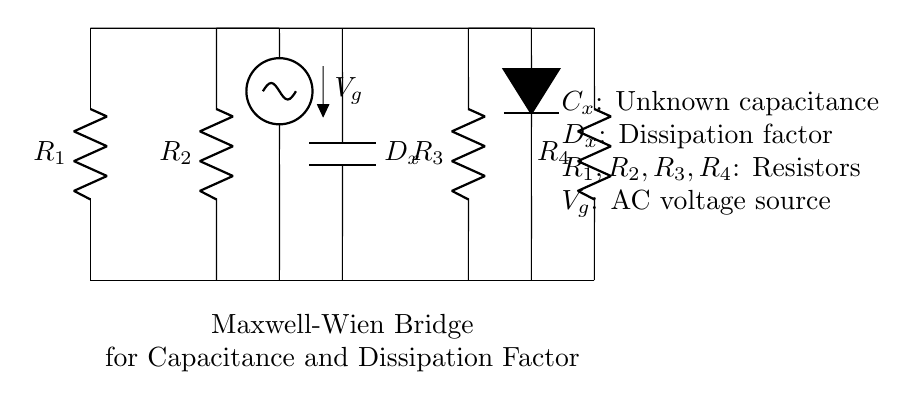What is the purpose of the capacitor in this bridge circuit? The capacitor, labeled as C_x, is used to measure the unknown capacitance in the experiment, and it is crucial for determining the dissipation factor in conjunction with the resistors.
Answer: Measure capacitance What are the components connected to the AC voltage source? The components connected to the AC voltage source, labeled as V_g, are the resistor R_2 and the resistor R_4, which are part of the measuring section of the bridge.
Answer: R_2 and R_4 How many resistors are present in this circuit? There are four resistors present, specifically R_1, R_2, R_3, and R_4, which form the necessary parts of the Maxwell-Wien bridge.
Answer: Four What does D_x represent in the circuit? D_x represents the dissipation factor, which indicates the loss of energy in the capacitor and is an essential parameter for analyzing its performance.
Answer: Dissipation factor If R_1 is equal to R_3, and R_2 equals R_4, what can be deduced about the bridge? If R_1 equals R_3 and R_2 equals R_4, the bridge is balanced, and the measurement of the capacitance can be accurately determined, indicating that the network reaches a state where all voltages are equal across the relevant nodes.
Answer: Balanced bridge What is the significance of the unknown capacitor C_x in this circuit setup? The significance of C_x is that it is the unknown capacitor whose value is being determined through the measurement techniques applied in the bridge circuit, which also allows for the computation of the dissipation factor.
Answer: Unknown capacitance 